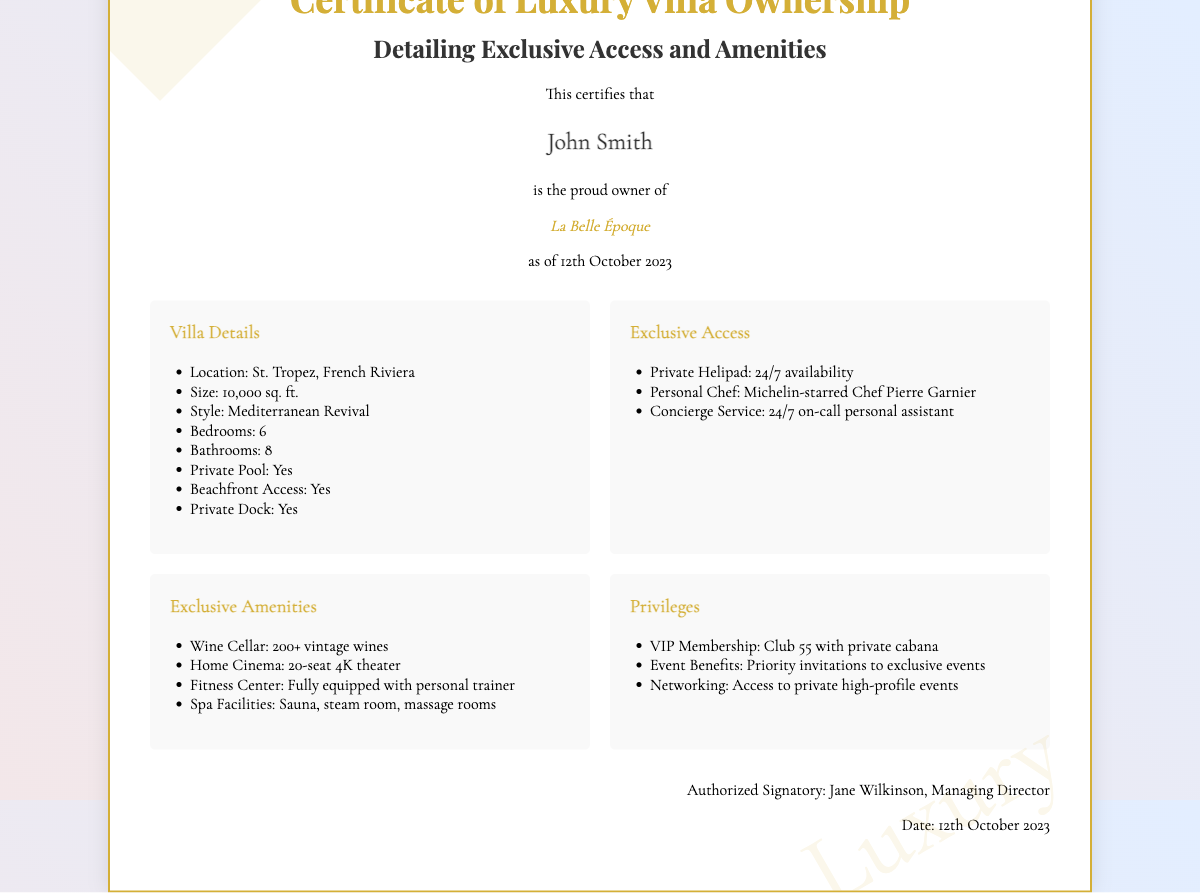what is the owner’s name? The owner's name is explicitly stated in the document as John Smith.
Answer: John Smith what is the name of the villa? The villa's name is mentioned in the document as La Belle Époque.
Answer: La Belle Époque when was the certificate issued? The date when the certificate was issued is noted as 12th October 2023.
Answer: 12th October 2023 what is the size of the villa? The size of the villa is provided in square feet as 10,000 sq. ft.
Answer: 10,000 sq. ft how many bedrooms does the villa have? The document lists the number of bedrooms in the villa as 6.
Answer: 6 what exclusive amenity features a personal trainer? The fitness center is described as fully equipped with a personal trainer.
Answer: Fitness Center what is the name of the personal chef? The personal chef is identified in the document as Michelin-starred Chef Pierre Garnier.
Answer: Chef Pierre Garnier what privilege is associated with Club 55? The document states that there is VIP Membership linked to Club 55 with a private cabana.
Answer: Club 55 how many vintage wines are in the wine cellar? The wine cellar holds over 200 vintage wines, as outlined in the document.
Answer: 200+ vintage wines 